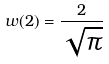<formula> <loc_0><loc_0><loc_500><loc_500>w ( 2 ) = \frac { 2 } { \sqrt { \pi } }</formula> 